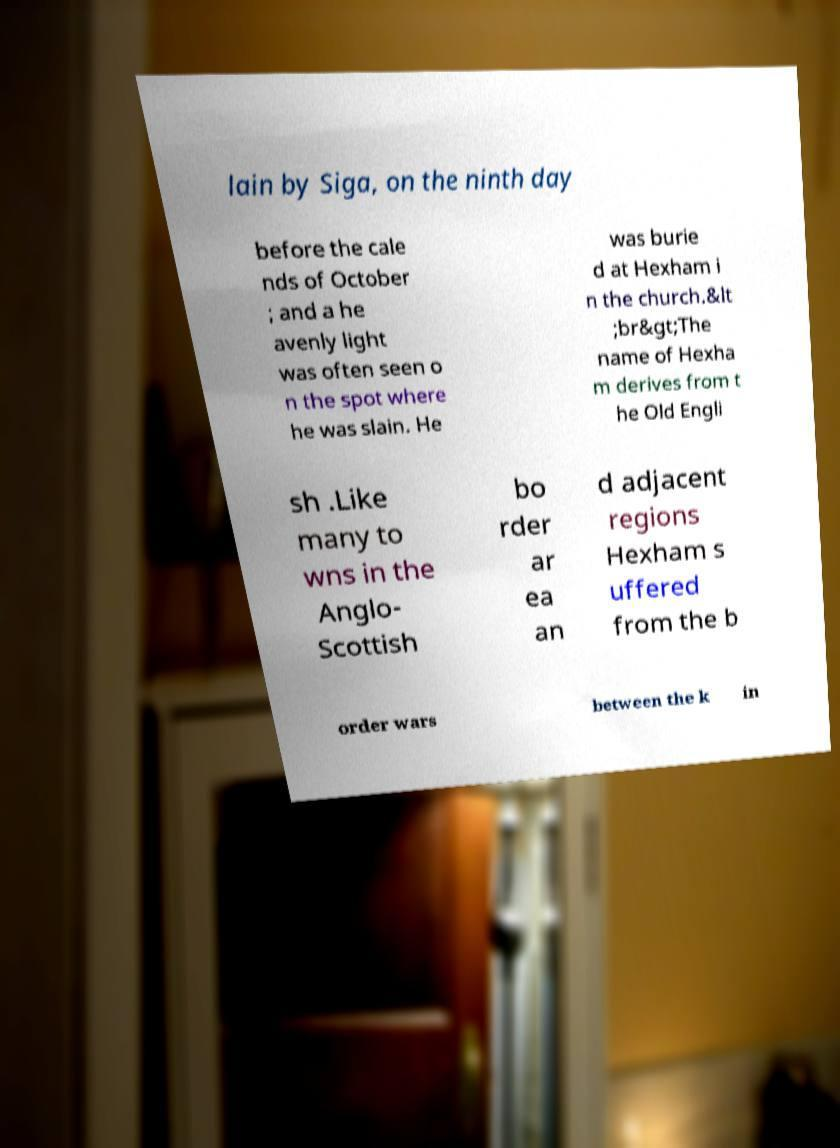Could you assist in decoding the text presented in this image and type it out clearly? lain by Siga, on the ninth day before the cale nds of October ; and a he avenly light was often seen o n the spot where he was slain. He was burie d at Hexham i n the church.&lt ;br&gt;The name of Hexha m derives from t he Old Engli sh .Like many to wns in the Anglo- Scottish bo rder ar ea an d adjacent regions Hexham s uffered from the b order wars between the k in 